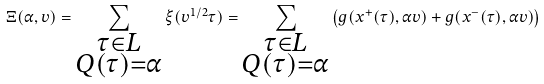<formula> <loc_0><loc_0><loc_500><loc_500>\Xi ( \alpha , v ) = \sum _ { \substack { \tau \in L \\ Q ( \tau ) = \alpha } } \xi ( v ^ { 1 / 2 } \tau ) = \sum _ { \substack { \tau \in L \\ Q ( \tau ) = \alpha } } \left ( g ( x ^ { + } ( \tau ) , \alpha v ) + g ( x ^ { - } ( \tau ) , \alpha v ) \right )</formula> 